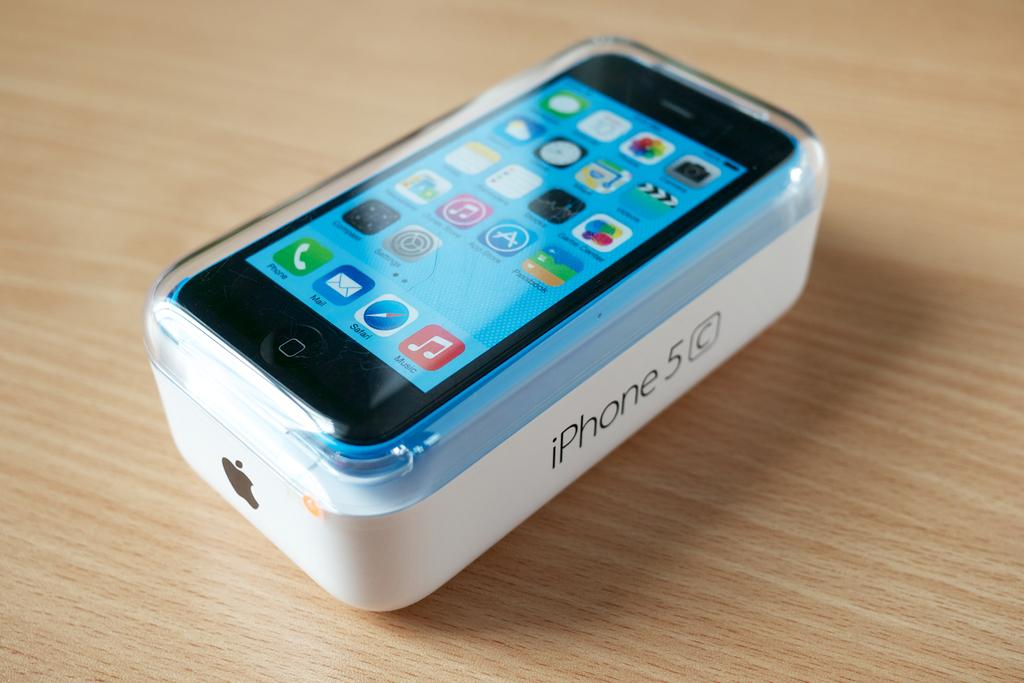<image>
Present a compact description of the photo's key features. A new iPhone 5 C is safely packed away in its case. 